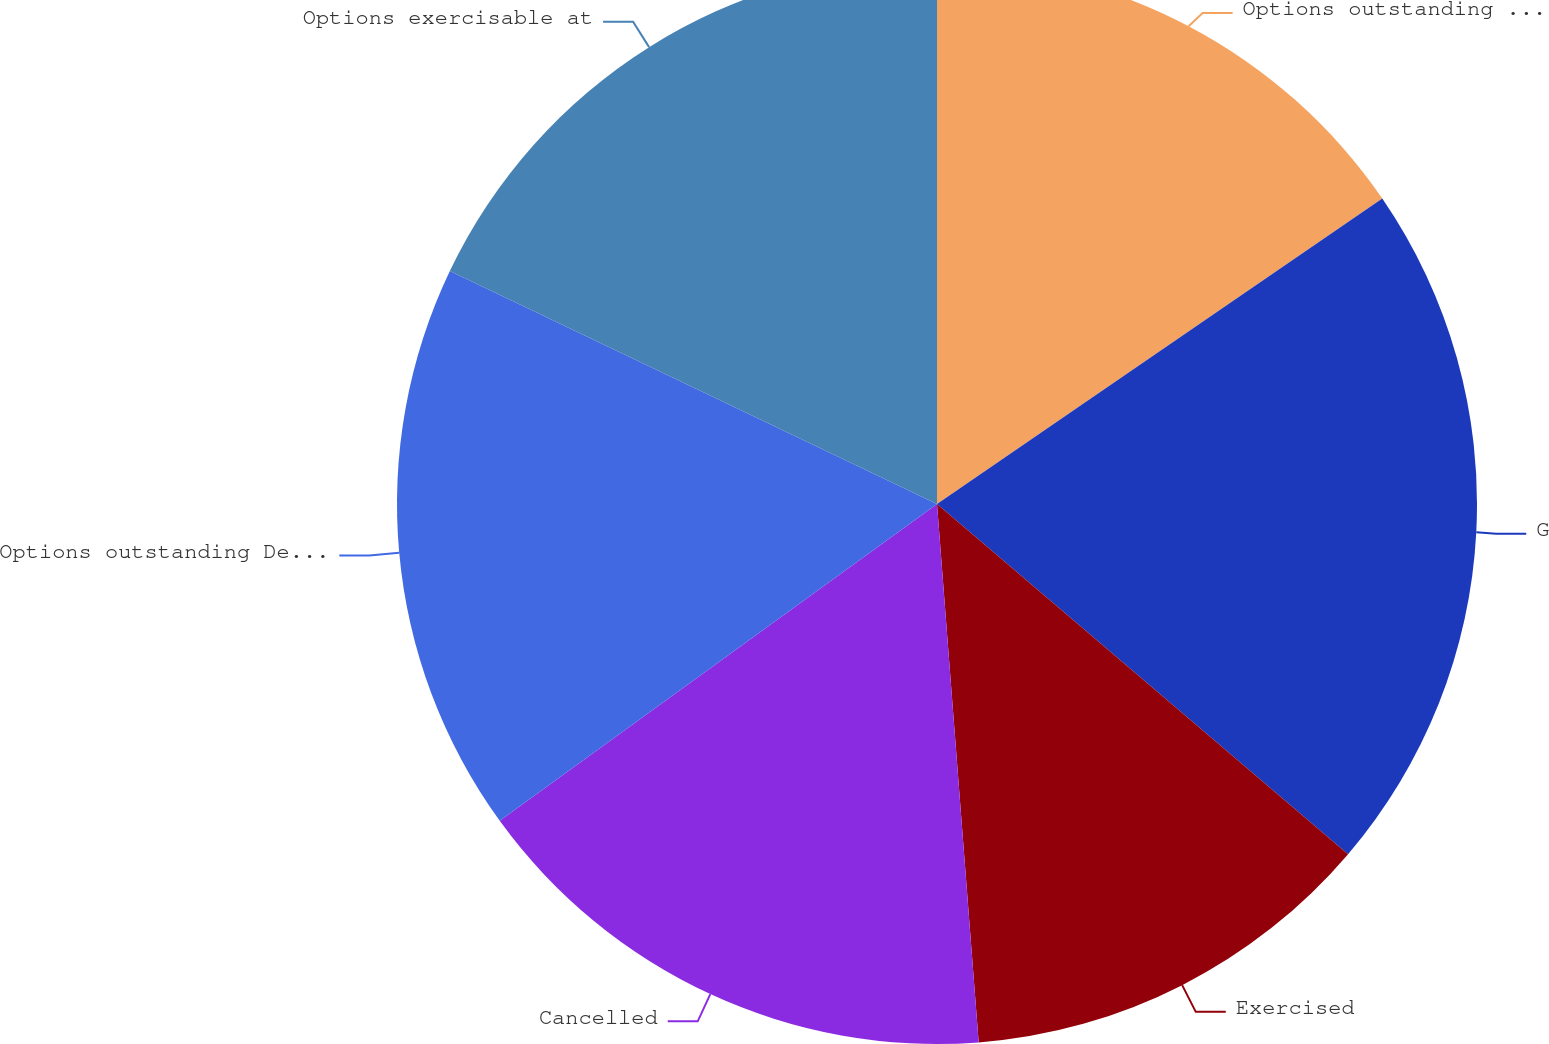Convert chart. <chart><loc_0><loc_0><loc_500><loc_500><pie_chart><fcel>Options outstanding January 1<fcel>Granted<fcel>Exercised<fcel>Cancelled<fcel>Options outstanding December<fcel>Options exercisable at<nl><fcel>15.43%<fcel>20.8%<fcel>12.54%<fcel>16.25%<fcel>17.08%<fcel>17.9%<nl></chart> 